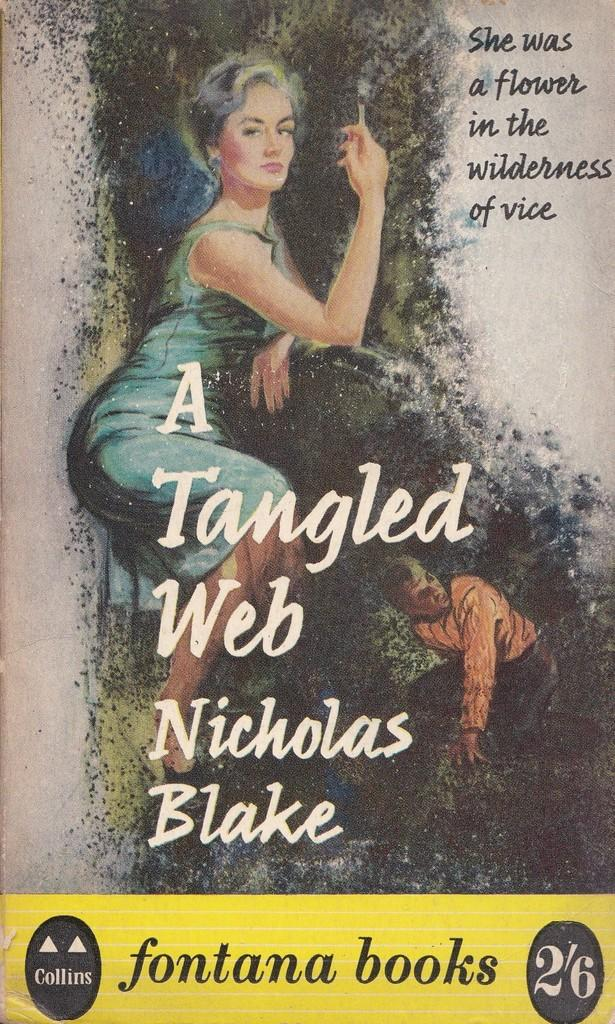<image>
Share a concise interpretation of the image provided. A book cover that was published by Fontana books. 